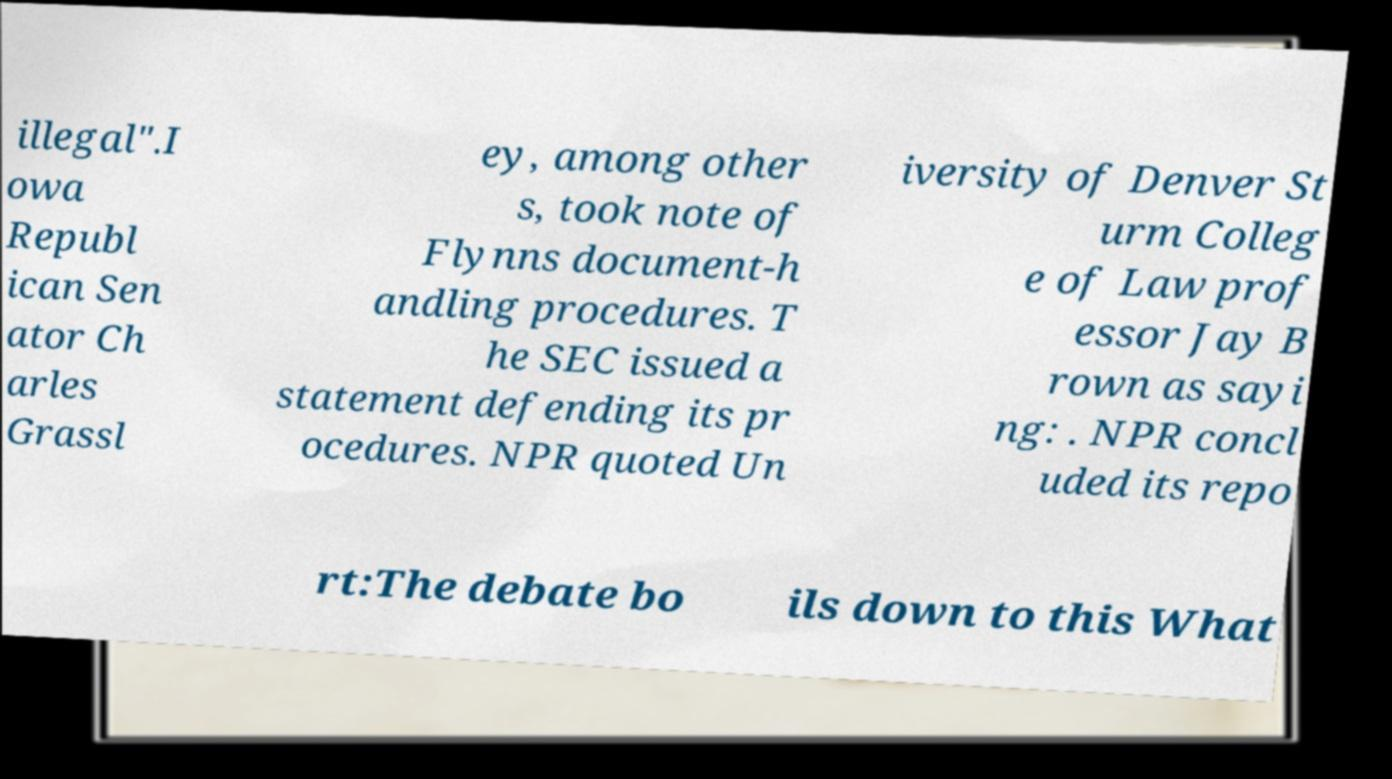I need the written content from this picture converted into text. Can you do that? illegal".I owa Republ ican Sen ator Ch arles Grassl ey, among other s, took note of Flynns document-h andling procedures. T he SEC issued a statement defending its pr ocedures. NPR quoted Un iversity of Denver St urm Colleg e of Law prof essor Jay B rown as sayi ng: . NPR concl uded its repo rt:The debate bo ils down to this What 